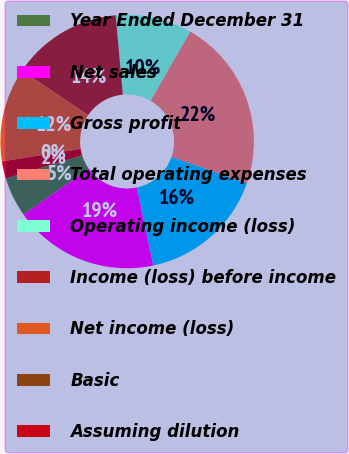<chart> <loc_0><loc_0><loc_500><loc_500><pie_chart><fcel>Year Ended December 31<fcel>Net sales<fcel>Gross profit<fcel>Total operating expenses<fcel>Operating income (loss)<fcel>Income (loss) before income<fcel>Net income (loss)<fcel>Basic<fcel>Assuming dilution<nl><fcel>5.06%<fcel>18.54%<fcel>16.34%<fcel>22.05%<fcel>9.73%<fcel>14.13%<fcel>11.93%<fcel>0.01%<fcel>2.21%<nl></chart> 